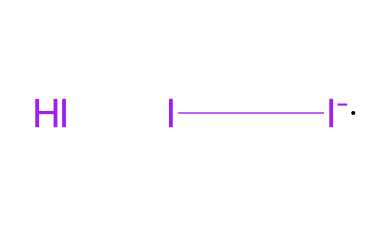What is the molecular formula of this chemical? The SMILES representation shows that there is one iodine atom and one iodide ion present, which corresponds to the formula I[I-].I, indicating a combination of iodine (I) and iodide (I-).
Answer: I3 How many total atoms are in the structure? By analyzing the SMILES, we see three iodine entities: one iodine molecule and two iodine ions. Therefore, the total number of atoms is three.
Answer: 3 What type of bond is present in this chemical structure? The SMILES indicates that the iodine atoms are connected, which forms covalent bonds between them since they are non-metals.
Answer: covalent What does the presence of the iodide ion imply about the solution? The presence of the iodide ion, indicated by [I-], suggests that the solution is likely ionic and could have a properties such as conductivity in solution.
Answer: ionic Is this chemical an element or a compound? The structure indicates that it is made up of multiple iodine atoms rather than just one type, suggesting it is a compound formed from elemental iodine.
Answer: compound Which halogen does this chemical belong to? Since the chemical comprises iodine, which is a member of the halogen group in the periodic table, it belongs to the halogens.
Answer: iodine 